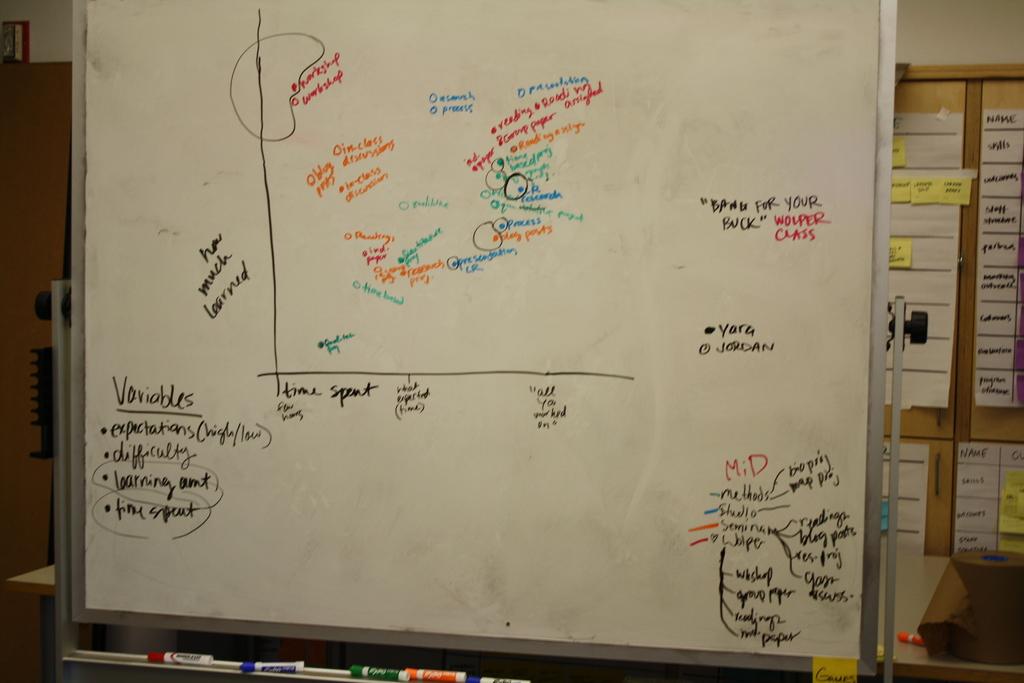What is the title on the bottom left of the dry erase board?
Provide a succinct answer. Variables. 